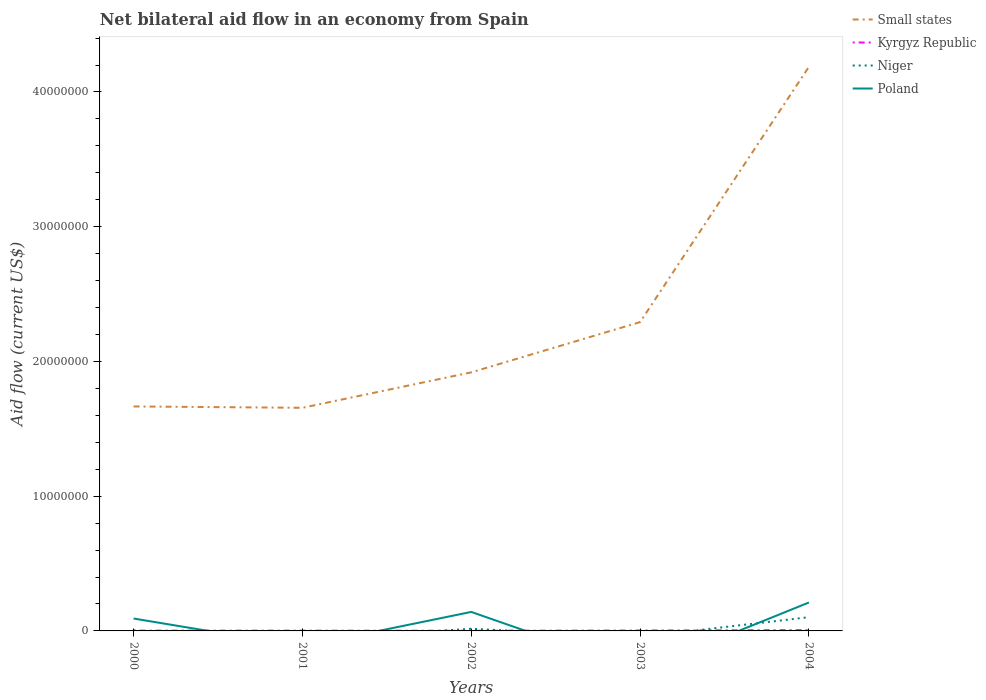How many different coloured lines are there?
Your answer should be compact. 4. What is the total net bilateral aid flow in Small states in the graph?
Keep it short and to the point. -2.63e+06. What is the difference between the highest and the second highest net bilateral aid flow in Kyrgyz Republic?
Your response must be concise. 5.00e+04. What is the difference between the highest and the lowest net bilateral aid flow in Niger?
Your response must be concise. 1. Is the net bilateral aid flow in Niger strictly greater than the net bilateral aid flow in Small states over the years?
Make the answer very short. Yes. How many lines are there?
Provide a succinct answer. 4. What is the difference between two consecutive major ticks on the Y-axis?
Your answer should be very brief. 1.00e+07. Does the graph contain grids?
Your answer should be compact. No. Where does the legend appear in the graph?
Your response must be concise. Top right. What is the title of the graph?
Make the answer very short. Net bilateral aid flow in an economy from Spain. What is the label or title of the X-axis?
Your answer should be compact. Years. What is the Aid flow (current US$) in Small states in 2000?
Provide a short and direct response. 1.67e+07. What is the Aid flow (current US$) in Kyrgyz Republic in 2000?
Offer a very short reply. 2.00e+04. What is the Aid flow (current US$) of Niger in 2000?
Make the answer very short. 3.00e+04. What is the Aid flow (current US$) of Poland in 2000?
Your answer should be very brief. 9.20e+05. What is the Aid flow (current US$) of Small states in 2001?
Offer a very short reply. 1.66e+07. What is the Aid flow (current US$) in Small states in 2002?
Make the answer very short. 1.92e+07. What is the Aid flow (current US$) in Kyrgyz Republic in 2002?
Offer a very short reply. 10000. What is the Aid flow (current US$) in Poland in 2002?
Ensure brevity in your answer.  1.41e+06. What is the Aid flow (current US$) in Small states in 2003?
Provide a succinct answer. 2.29e+07. What is the Aid flow (current US$) in Kyrgyz Republic in 2003?
Offer a very short reply. 3.00e+04. What is the Aid flow (current US$) of Niger in 2003?
Give a very brief answer. 0. What is the Aid flow (current US$) in Poland in 2003?
Your answer should be compact. 0. What is the Aid flow (current US$) in Small states in 2004?
Your answer should be compact. 4.19e+07. What is the Aid flow (current US$) of Niger in 2004?
Offer a very short reply. 1.02e+06. What is the Aid flow (current US$) of Poland in 2004?
Keep it short and to the point. 2.11e+06. Across all years, what is the maximum Aid flow (current US$) in Small states?
Give a very brief answer. 4.19e+07. Across all years, what is the maximum Aid flow (current US$) in Niger?
Your answer should be compact. 1.02e+06. Across all years, what is the maximum Aid flow (current US$) in Poland?
Provide a short and direct response. 2.11e+06. Across all years, what is the minimum Aid flow (current US$) of Small states?
Ensure brevity in your answer.  1.66e+07. Across all years, what is the minimum Aid flow (current US$) in Kyrgyz Republic?
Offer a very short reply. 10000. What is the total Aid flow (current US$) of Small states in the graph?
Keep it short and to the point. 1.17e+08. What is the total Aid flow (current US$) in Niger in the graph?
Give a very brief answer. 1.21e+06. What is the total Aid flow (current US$) of Poland in the graph?
Give a very brief answer. 4.44e+06. What is the difference between the Aid flow (current US$) of Small states in 2000 and that in 2001?
Ensure brevity in your answer.  1.00e+05. What is the difference between the Aid flow (current US$) in Kyrgyz Republic in 2000 and that in 2001?
Offer a terse response. 0. What is the difference between the Aid flow (current US$) in Small states in 2000 and that in 2002?
Provide a short and direct response. -2.53e+06. What is the difference between the Aid flow (current US$) in Niger in 2000 and that in 2002?
Your answer should be very brief. -1.30e+05. What is the difference between the Aid flow (current US$) of Poland in 2000 and that in 2002?
Give a very brief answer. -4.90e+05. What is the difference between the Aid flow (current US$) in Small states in 2000 and that in 2003?
Your answer should be compact. -6.26e+06. What is the difference between the Aid flow (current US$) in Kyrgyz Republic in 2000 and that in 2003?
Make the answer very short. -10000. What is the difference between the Aid flow (current US$) of Small states in 2000 and that in 2004?
Provide a succinct answer. -2.52e+07. What is the difference between the Aid flow (current US$) of Kyrgyz Republic in 2000 and that in 2004?
Provide a succinct answer. -4.00e+04. What is the difference between the Aid flow (current US$) in Niger in 2000 and that in 2004?
Your answer should be compact. -9.90e+05. What is the difference between the Aid flow (current US$) of Poland in 2000 and that in 2004?
Ensure brevity in your answer.  -1.19e+06. What is the difference between the Aid flow (current US$) of Small states in 2001 and that in 2002?
Your response must be concise. -2.63e+06. What is the difference between the Aid flow (current US$) in Kyrgyz Republic in 2001 and that in 2002?
Your answer should be very brief. 10000. What is the difference between the Aid flow (current US$) of Small states in 2001 and that in 2003?
Keep it short and to the point. -6.36e+06. What is the difference between the Aid flow (current US$) in Kyrgyz Republic in 2001 and that in 2003?
Ensure brevity in your answer.  -10000. What is the difference between the Aid flow (current US$) of Small states in 2001 and that in 2004?
Offer a very short reply. -2.53e+07. What is the difference between the Aid flow (current US$) in Small states in 2002 and that in 2003?
Offer a very short reply. -3.73e+06. What is the difference between the Aid flow (current US$) of Kyrgyz Republic in 2002 and that in 2003?
Make the answer very short. -2.00e+04. What is the difference between the Aid flow (current US$) of Small states in 2002 and that in 2004?
Offer a very short reply. -2.27e+07. What is the difference between the Aid flow (current US$) of Kyrgyz Republic in 2002 and that in 2004?
Ensure brevity in your answer.  -5.00e+04. What is the difference between the Aid flow (current US$) of Niger in 2002 and that in 2004?
Offer a very short reply. -8.60e+05. What is the difference between the Aid flow (current US$) in Poland in 2002 and that in 2004?
Offer a very short reply. -7.00e+05. What is the difference between the Aid flow (current US$) in Small states in 2003 and that in 2004?
Offer a terse response. -1.90e+07. What is the difference between the Aid flow (current US$) in Kyrgyz Republic in 2003 and that in 2004?
Ensure brevity in your answer.  -3.00e+04. What is the difference between the Aid flow (current US$) in Small states in 2000 and the Aid flow (current US$) in Kyrgyz Republic in 2001?
Make the answer very short. 1.66e+07. What is the difference between the Aid flow (current US$) in Small states in 2000 and the Aid flow (current US$) in Kyrgyz Republic in 2002?
Make the answer very short. 1.66e+07. What is the difference between the Aid flow (current US$) of Small states in 2000 and the Aid flow (current US$) of Niger in 2002?
Ensure brevity in your answer.  1.65e+07. What is the difference between the Aid flow (current US$) of Small states in 2000 and the Aid flow (current US$) of Poland in 2002?
Offer a terse response. 1.52e+07. What is the difference between the Aid flow (current US$) in Kyrgyz Republic in 2000 and the Aid flow (current US$) in Poland in 2002?
Your answer should be very brief. -1.39e+06. What is the difference between the Aid flow (current US$) of Niger in 2000 and the Aid flow (current US$) of Poland in 2002?
Your answer should be compact. -1.38e+06. What is the difference between the Aid flow (current US$) in Small states in 2000 and the Aid flow (current US$) in Kyrgyz Republic in 2003?
Your answer should be very brief. 1.66e+07. What is the difference between the Aid flow (current US$) in Small states in 2000 and the Aid flow (current US$) in Kyrgyz Republic in 2004?
Offer a terse response. 1.66e+07. What is the difference between the Aid flow (current US$) in Small states in 2000 and the Aid flow (current US$) in Niger in 2004?
Your answer should be compact. 1.56e+07. What is the difference between the Aid flow (current US$) in Small states in 2000 and the Aid flow (current US$) in Poland in 2004?
Keep it short and to the point. 1.46e+07. What is the difference between the Aid flow (current US$) in Kyrgyz Republic in 2000 and the Aid flow (current US$) in Niger in 2004?
Provide a succinct answer. -1.00e+06. What is the difference between the Aid flow (current US$) in Kyrgyz Republic in 2000 and the Aid flow (current US$) in Poland in 2004?
Offer a very short reply. -2.09e+06. What is the difference between the Aid flow (current US$) of Niger in 2000 and the Aid flow (current US$) of Poland in 2004?
Keep it short and to the point. -2.08e+06. What is the difference between the Aid flow (current US$) of Small states in 2001 and the Aid flow (current US$) of Kyrgyz Republic in 2002?
Provide a succinct answer. 1.66e+07. What is the difference between the Aid flow (current US$) of Small states in 2001 and the Aid flow (current US$) of Niger in 2002?
Offer a very short reply. 1.64e+07. What is the difference between the Aid flow (current US$) of Small states in 2001 and the Aid flow (current US$) of Poland in 2002?
Give a very brief answer. 1.52e+07. What is the difference between the Aid flow (current US$) in Kyrgyz Republic in 2001 and the Aid flow (current US$) in Poland in 2002?
Your response must be concise. -1.39e+06. What is the difference between the Aid flow (current US$) in Small states in 2001 and the Aid flow (current US$) in Kyrgyz Republic in 2003?
Your response must be concise. 1.65e+07. What is the difference between the Aid flow (current US$) in Small states in 2001 and the Aid flow (current US$) in Kyrgyz Republic in 2004?
Keep it short and to the point. 1.65e+07. What is the difference between the Aid flow (current US$) in Small states in 2001 and the Aid flow (current US$) in Niger in 2004?
Offer a terse response. 1.55e+07. What is the difference between the Aid flow (current US$) in Small states in 2001 and the Aid flow (current US$) in Poland in 2004?
Make the answer very short. 1.44e+07. What is the difference between the Aid flow (current US$) of Kyrgyz Republic in 2001 and the Aid flow (current US$) of Niger in 2004?
Ensure brevity in your answer.  -1.00e+06. What is the difference between the Aid flow (current US$) in Kyrgyz Republic in 2001 and the Aid flow (current US$) in Poland in 2004?
Provide a succinct answer. -2.09e+06. What is the difference between the Aid flow (current US$) in Small states in 2002 and the Aid flow (current US$) in Kyrgyz Republic in 2003?
Your answer should be compact. 1.92e+07. What is the difference between the Aid flow (current US$) of Small states in 2002 and the Aid flow (current US$) of Kyrgyz Republic in 2004?
Your answer should be very brief. 1.91e+07. What is the difference between the Aid flow (current US$) of Small states in 2002 and the Aid flow (current US$) of Niger in 2004?
Ensure brevity in your answer.  1.82e+07. What is the difference between the Aid flow (current US$) in Small states in 2002 and the Aid flow (current US$) in Poland in 2004?
Give a very brief answer. 1.71e+07. What is the difference between the Aid flow (current US$) in Kyrgyz Republic in 2002 and the Aid flow (current US$) in Niger in 2004?
Give a very brief answer. -1.01e+06. What is the difference between the Aid flow (current US$) of Kyrgyz Republic in 2002 and the Aid flow (current US$) of Poland in 2004?
Your response must be concise. -2.10e+06. What is the difference between the Aid flow (current US$) in Niger in 2002 and the Aid flow (current US$) in Poland in 2004?
Provide a short and direct response. -1.95e+06. What is the difference between the Aid flow (current US$) in Small states in 2003 and the Aid flow (current US$) in Kyrgyz Republic in 2004?
Give a very brief answer. 2.29e+07. What is the difference between the Aid flow (current US$) of Small states in 2003 and the Aid flow (current US$) of Niger in 2004?
Provide a succinct answer. 2.19e+07. What is the difference between the Aid flow (current US$) in Small states in 2003 and the Aid flow (current US$) in Poland in 2004?
Keep it short and to the point. 2.08e+07. What is the difference between the Aid flow (current US$) of Kyrgyz Republic in 2003 and the Aid flow (current US$) of Niger in 2004?
Offer a very short reply. -9.90e+05. What is the difference between the Aid flow (current US$) in Kyrgyz Republic in 2003 and the Aid flow (current US$) in Poland in 2004?
Give a very brief answer. -2.08e+06. What is the average Aid flow (current US$) of Small states per year?
Provide a short and direct response. 2.34e+07. What is the average Aid flow (current US$) in Kyrgyz Republic per year?
Offer a terse response. 2.80e+04. What is the average Aid flow (current US$) of Niger per year?
Provide a short and direct response. 2.42e+05. What is the average Aid flow (current US$) of Poland per year?
Make the answer very short. 8.88e+05. In the year 2000, what is the difference between the Aid flow (current US$) in Small states and Aid flow (current US$) in Kyrgyz Republic?
Make the answer very short. 1.66e+07. In the year 2000, what is the difference between the Aid flow (current US$) in Small states and Aid flow (current US$) in Niger?
Keep it short and to the point. 1.66e+07. In the year 2000, what is the difference between the Aid flow (current US$) of Small states and Aid flow (current US$) of Poland?
Your answer should be very brief. 1.57e+07. In the year 2000, what is the difference between the Aid flow (current US$) in Kyrgyz Republic and Aid flow (current US$) in Poland?
Provide a short and direct response. -9.00e+05. In the year 2000, what is the difference between the Aid flow (current US$) of Niger and Aid flow (current US$) of Poland?
Ensure brevity in your answer.  -8.90e+05. In the year 2001, what is the difference between the Aid flow (current US$) of Small states and Aid flow (current US$) of Kyrgyz Republic?
Your answer should be compact. 1.65e+07. In the year 2002, what is the difference between the Aid flow (current US$) of Small states and Aid flow (current US$) of Kyrgyz Republic?
Provide a succinct answer. 1.92e+07. In the year 2002, what is the difference between the Aid flow (current US$) of Small states and Aid flow (current US$) of Niger?
Provide a short and direct response. 1.90e+07. In the year 2002, what is the difference between the Aid flow (current US$) in Small states and Aid flow (current US$) in Poland?
Offer a very short reply. 1.78e+07. In the year 2002, what is the difference between the Aid flow (current US$) of Kyrgyz Republic and Aid flow (current US$) of Poland?
Provide a succinct answer. -1.40e+06. In the year 2002, what is the difference between the Aid flow (current US$) in Niger and Aid flow (current US$) in Poland?
Provide a short and direct response. -1.25e+06. In the year 2003, what is the difference between the Aid flow (current US$) of Small states and Aid flow (current US$) of Kyrgyz Republic?
Ensure brevity in your answer.  2.29e+07. In the year 2004, what is the difference between the Aid flow (current US$) of Small states and Aid flow (current US$) of Kyrgyz Republic?
Make the answer very short. 4.18e+07. In the year 2004, what is the difference between the Aid flow (current US$) of Small states and Aid flow (current US$) of Niger?
Your answer should be compact. 4.08e+07. In the year 2004, what is the difference between the Aid flow (current US$) of Small states and Aid flow (current US$) of Poland?
Give a very brief answer. 3.98e+07. In the year 2004, what is the difference between the Aid flow (current US$) of Kyrgyz Republic and Aid flow (current US$) of Niger?
Provide a succinct answer. -9.60e+05. In the year 2004, what is the difference between the Aid flow (current US$) of Kyrgyz Republic and Aid flow (current US$) of Poland?
Offer a very short reply. -2.05e+06. In the year 2004, what is the difference between the Aid flow (current US$) of Niger and Aid flow (current US$) of Poland?
Offer a very short reply. -1.09e+06. What is the ratio of the Aid flow (current US$) in Kyrgyz Republic in 2000 to that in 2001?
Your response must be concise. 1. What is the ratio of the Aid flow (current US$) of Small states in 2000 to that in 2002?
Your answer should be compact. 0.87. What is the ratio of the Aid flow (current US$) of Niger in 2000 to that in 2002?
Provide a short and direct response. 0.19. What is the ratio of the Aid flow (current US$) in Poland in 2000 to that in 2002?
Offer a very short reply. 0.65. What is the ratio of the Aid flow (current US$) of Small states in 2000 to that in 2003?
Offer a very short reply. 0.73. What is the ratio of the Aid flow (current US$) of Small states in 2000 to that in 2004?
Your answer should be very brief. 0.4. What is the ratio of the Aid flow (current US$) of Niger in 2000 to that in 2004?
Provide a succinct answer. 0.03. What is the ratio of the Aid flow (current US$) in Poland in 2000 to that in 2004?
Make the answer very short. 0.44. What is the ratio of the Aid flow (current US$) of Small states in 2001 to that in 2002?
Provide a short and direct response. 0.86. What is the ratio of the Aid flow (current US$) in Small states in 2001 to that in 2003?
Offer a very short reply. 0.72. What is the ratio of the Aid flow (current US$) of Kyrgyz Republic in 2001 to that in 2003?
Offer a terse response. 0.67. What is the ratio of the Aid flow (current US$) of Small states in 2001 to that in 2004?
Offer a very short reply. 0.4. What is the ratio of the Aid flow (current US$) of Kyrgyz Republic in 2001 to that in 2004?
Offer a very short reply. 0.33. What is the ratio of the Aid flow (current US$) of Small states in 2002 to that in 2003?
Your answer should be very brief. 0.84. What is the ratio of the Aid flow (current US$) in Kyrgyz Republic in 2002 to that in 2003?
Keep it short and to the point. 0.33. What is the ratio of the Aid flow (current US$) of Small states in 2002 to that in 2004?
Provide a short and direct response. 0.46. What is the ratio of the Aid flow (current US$) of Niger in 2002 to that in 2004?
Your answer should be very brief. 0.16. What is the ratio of the Aid flow (current US$) in Poland in 2002 to that in 2004?
Offer a terse response. 0.67. What is the ratio of the Aid flow (current US$) of Small states in 2003 to that in 2004?
Offer a very short reply. 0.55. What is the difference between the highest and the second highest Aid flow (current US$) of Small states?
Your answer should be very brief. 1.90e+07. What is the difference between the highest and the second highest Aid flow (current US$) in Kyrgyz Republic?
Offer a terse response. 3.00e+04. What is the difference between the highest and the second highest Aid flow (current US$) of Niger?
Your answer should be very brief. 8.60e+05. What is the difference between the highest and the lowest Aid flow (current US$) in Small states?
Your answer should be compact. 2.53e+07. What is the difference between the highest and the lowest Aid flow (current US$) of Niger?
Provide a short and direct response. 1.02e+06. What is the difference between the highest and the lowest Aid flow (current US$) of Poland?
Your answer should be compact. 2.11e+06. 